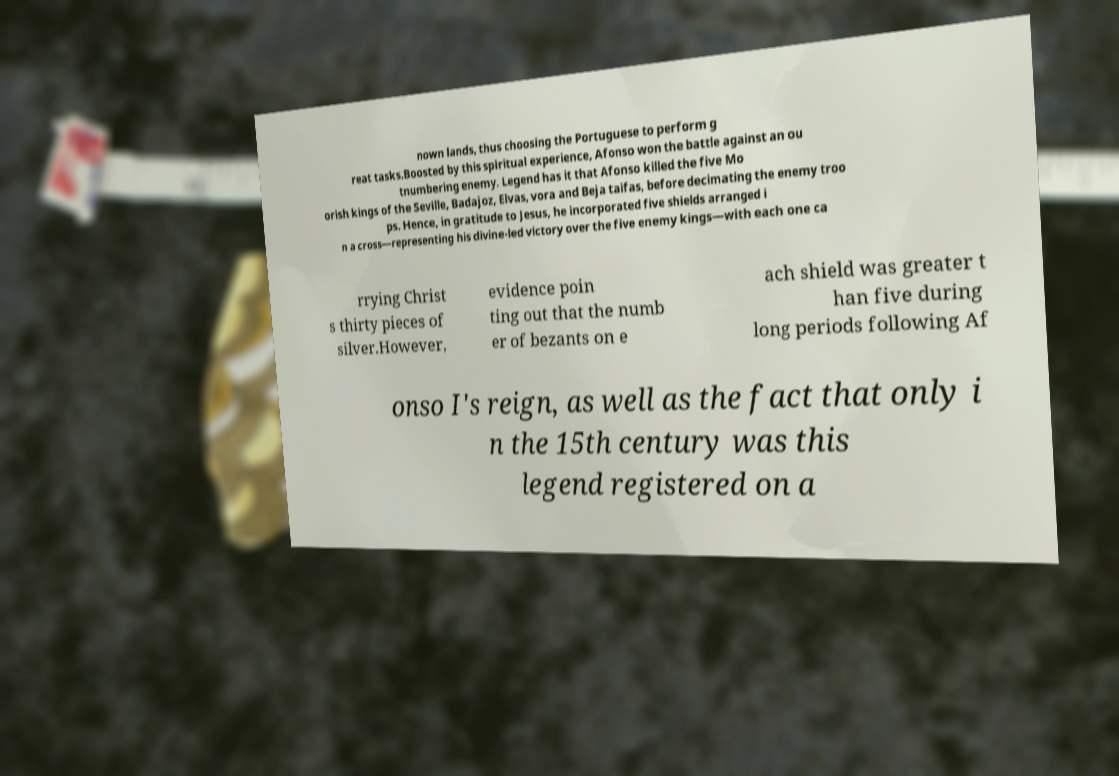Please read and relay the text visible in this image. What does it say? nown lands, thus choosing the Portuguese to perform g reat tasks.Boosted by this spiritual experience, Afonso won the battle against an ou tnumbering enemy. Legend has it that Afonso killed the five Mo orish kings of the Seville, Badajoz, Elvas, vora and Beja taifas, before decimating the enemy troo ps. Hence, in gratitude to Jesus, he incorporated five shields arranged i n a cross—representing his divine-led victory over the five enemy kings—with each one ca rrying Christ s thirty pieces of silver.However, evidence poin ting out that the numb er of bezants on e ach shield was greater t han five during long periods following Af onso I's reign, as well as the fact that only i n the 15th century was this legend registered on a 